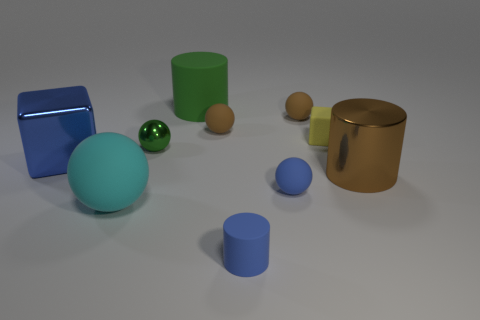Are there fewer shiny objects than small green balls?
Provide a succinct answer. No. What is the material of the block that is the same size as the cyan matte sphere?
Make the answer very short. Metal. What number of things are either metallic things or green metallic things?
Keep it short and to the point. 3. How many large matte objects are both behind the big brown cylinder and in front of the green rubber cylinder?
Make the answer very short. 0. Is the number of blue cylinders behind the blue shiny block less than the number of tiny blue shiny balls?
Offer a terse response. No. There is a green thing that is the same size as the blue rubber cylinder; what shape is it?
Your answer should be very brief. Sphere. What number of other things are the same color as the large shiny block?
Give a very brief answer. 2. Is the blue matte cylinder the same size as the green rubber cylinder?
Ensure brevity in your answer.  No. How many things are cyan things or matte spheres behind the blue cylinder?
Provide a short and direct response. 4. Is the number of large cyan balls behind the green rubber cylinder less than the number of metallic objects to the right of the tiny yellow matte thing?
Offer a terse response. Yes. 